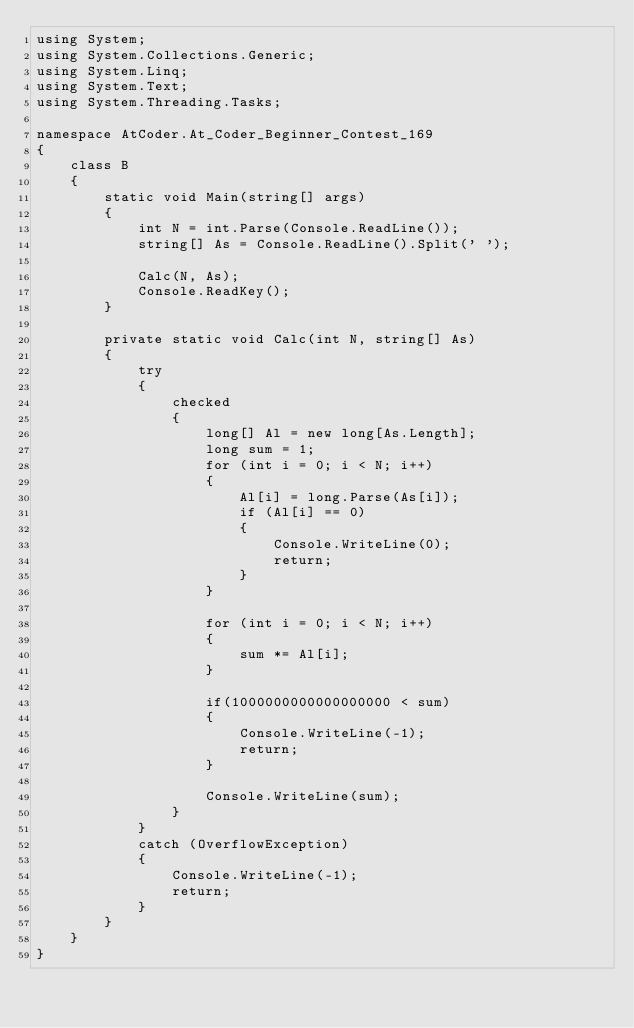Convert code to text. <code><loc_0><loc_0><loc_500><loc_500><_C#_>using System;
using System.Collections.Generic;
using System.Linq;
using System.Text;
using System.Threading.Tasks;

namespace AtCoder.At_Coder_Beginner_Contest_169
{
    class B
    {
        static void Main(string[] args)
        {
            int N = int.Parse(Console.ReadLine());
            string[] As = Console.ReadLine().Split(' ');

            Calc(N, As);
            Console.ReadKey();
        }

        private static void Calc(int N, string[] As)
        {
            try
            {
                checked
                {
                    long[] Al = new long[As.Length];
                    long sum = 1;
                    for (int i = 0; i < N; i++)
                    {
                        Al[i] = long.Parse(As[i]);
                        if (Al[i] == 0)
                        {
                            Console.WriteLine(0);
                            return;
                        }
                    }

                    for (int i = 0; i < N; i++)
                    {
                        sum *= Al[i];
                    }

                    if(1000000000000000000 < sum)
                    {
                        Console.WriteLine(-1);
                        return;
                    }

                    Console.WriteLine(sum);
                }
            }
            catch (OverflowException)
            {
                Console.WriteLine(-1);
                return;
            }
        }
    }
}
</code> 